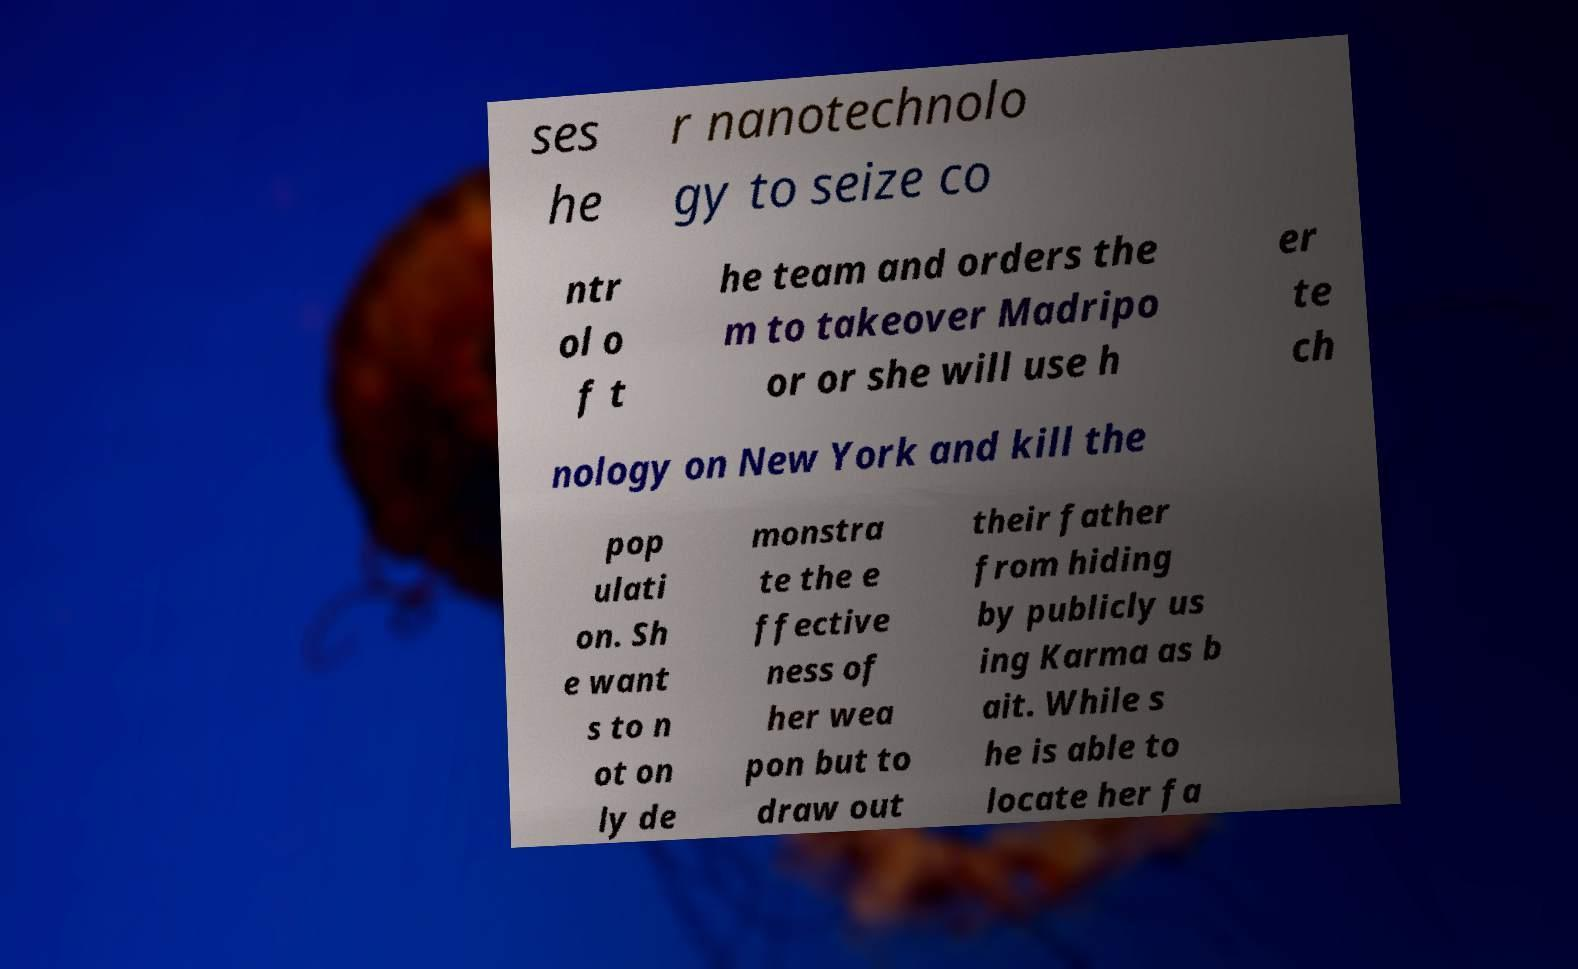Could you extract and type out the text from this image? ses he r nanotechnolo gy to seize co ntr ol o f t he team and orders the m to takeover Madripo or or she will use h er te ch nology on New York and kill the pop ulati on. Sh e want s to n ot on ly de monstra te the e ffective ness of her wea pon but to draw out their father from hiding by publicly us ing Karma as b ait. While s he is able to locate her fa 